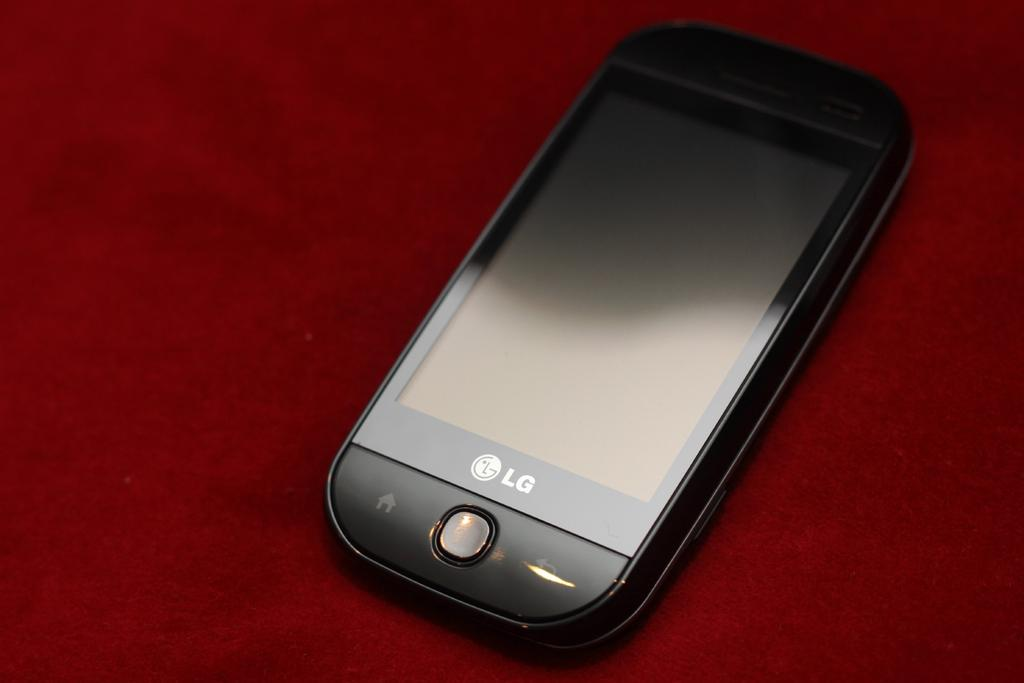<image>
Write a terse but informative summary of the picture. The black phone sitting on the red background is an LG mobile. 